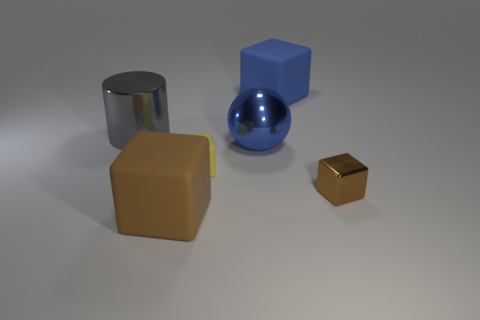There is a big blue thing in front of the large gray metal thing; what is its shape?
Provide a succinct answer. Sphere. There is a tiny object that is made of the same material as the blue ball; what is its color?
Offer a terse response. Brown. There is a blue object that is the same shape as the small brown object; what is it made of?
Offer a very short reply. Rubber. The large blue rubber object is what shape?
Keep it short and to the point. Cube. What material is the object that is both right of the yellow thing and in front of the yellow cube?
Your answer should be compact. Metal. There is a gray object that is the same material as the blue sphere; what shape is it?
Make the answer very short. Cylinder. What is the size of the brown block that is made of the same material as the big gray cylinder?
Your response must be concise. Small. The large object that is in front of the big blue matte object and right of the yellow matte thing has what shape?
Keep it short and to the point. Sphere. There is a blue metallic object that is behind the big matte block that is in front of the small brown metal thing; what size is it?
Your answer should be very brief. Large. How many other things are there of the same color as the big cylinder?
Your answer should be very brief. 0. 